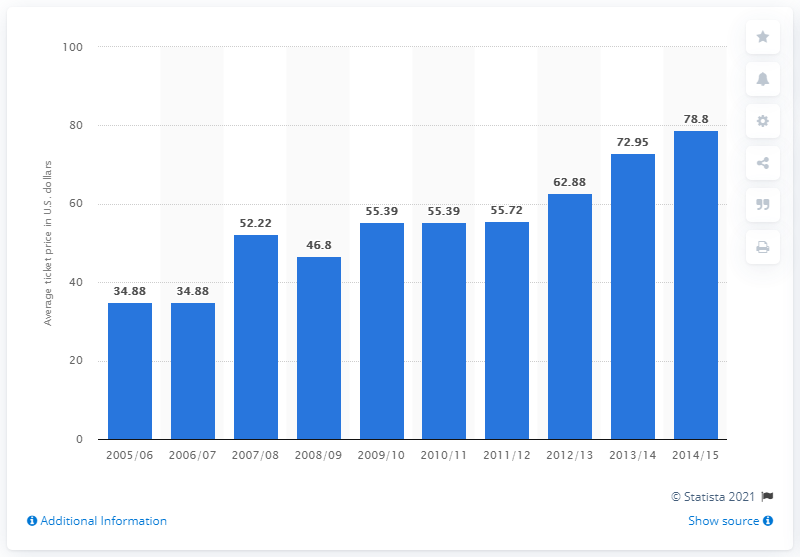Specify some key components in this picture. The average ticket price for a Blackhawks game during the 2005/2006 season was $34.88. 